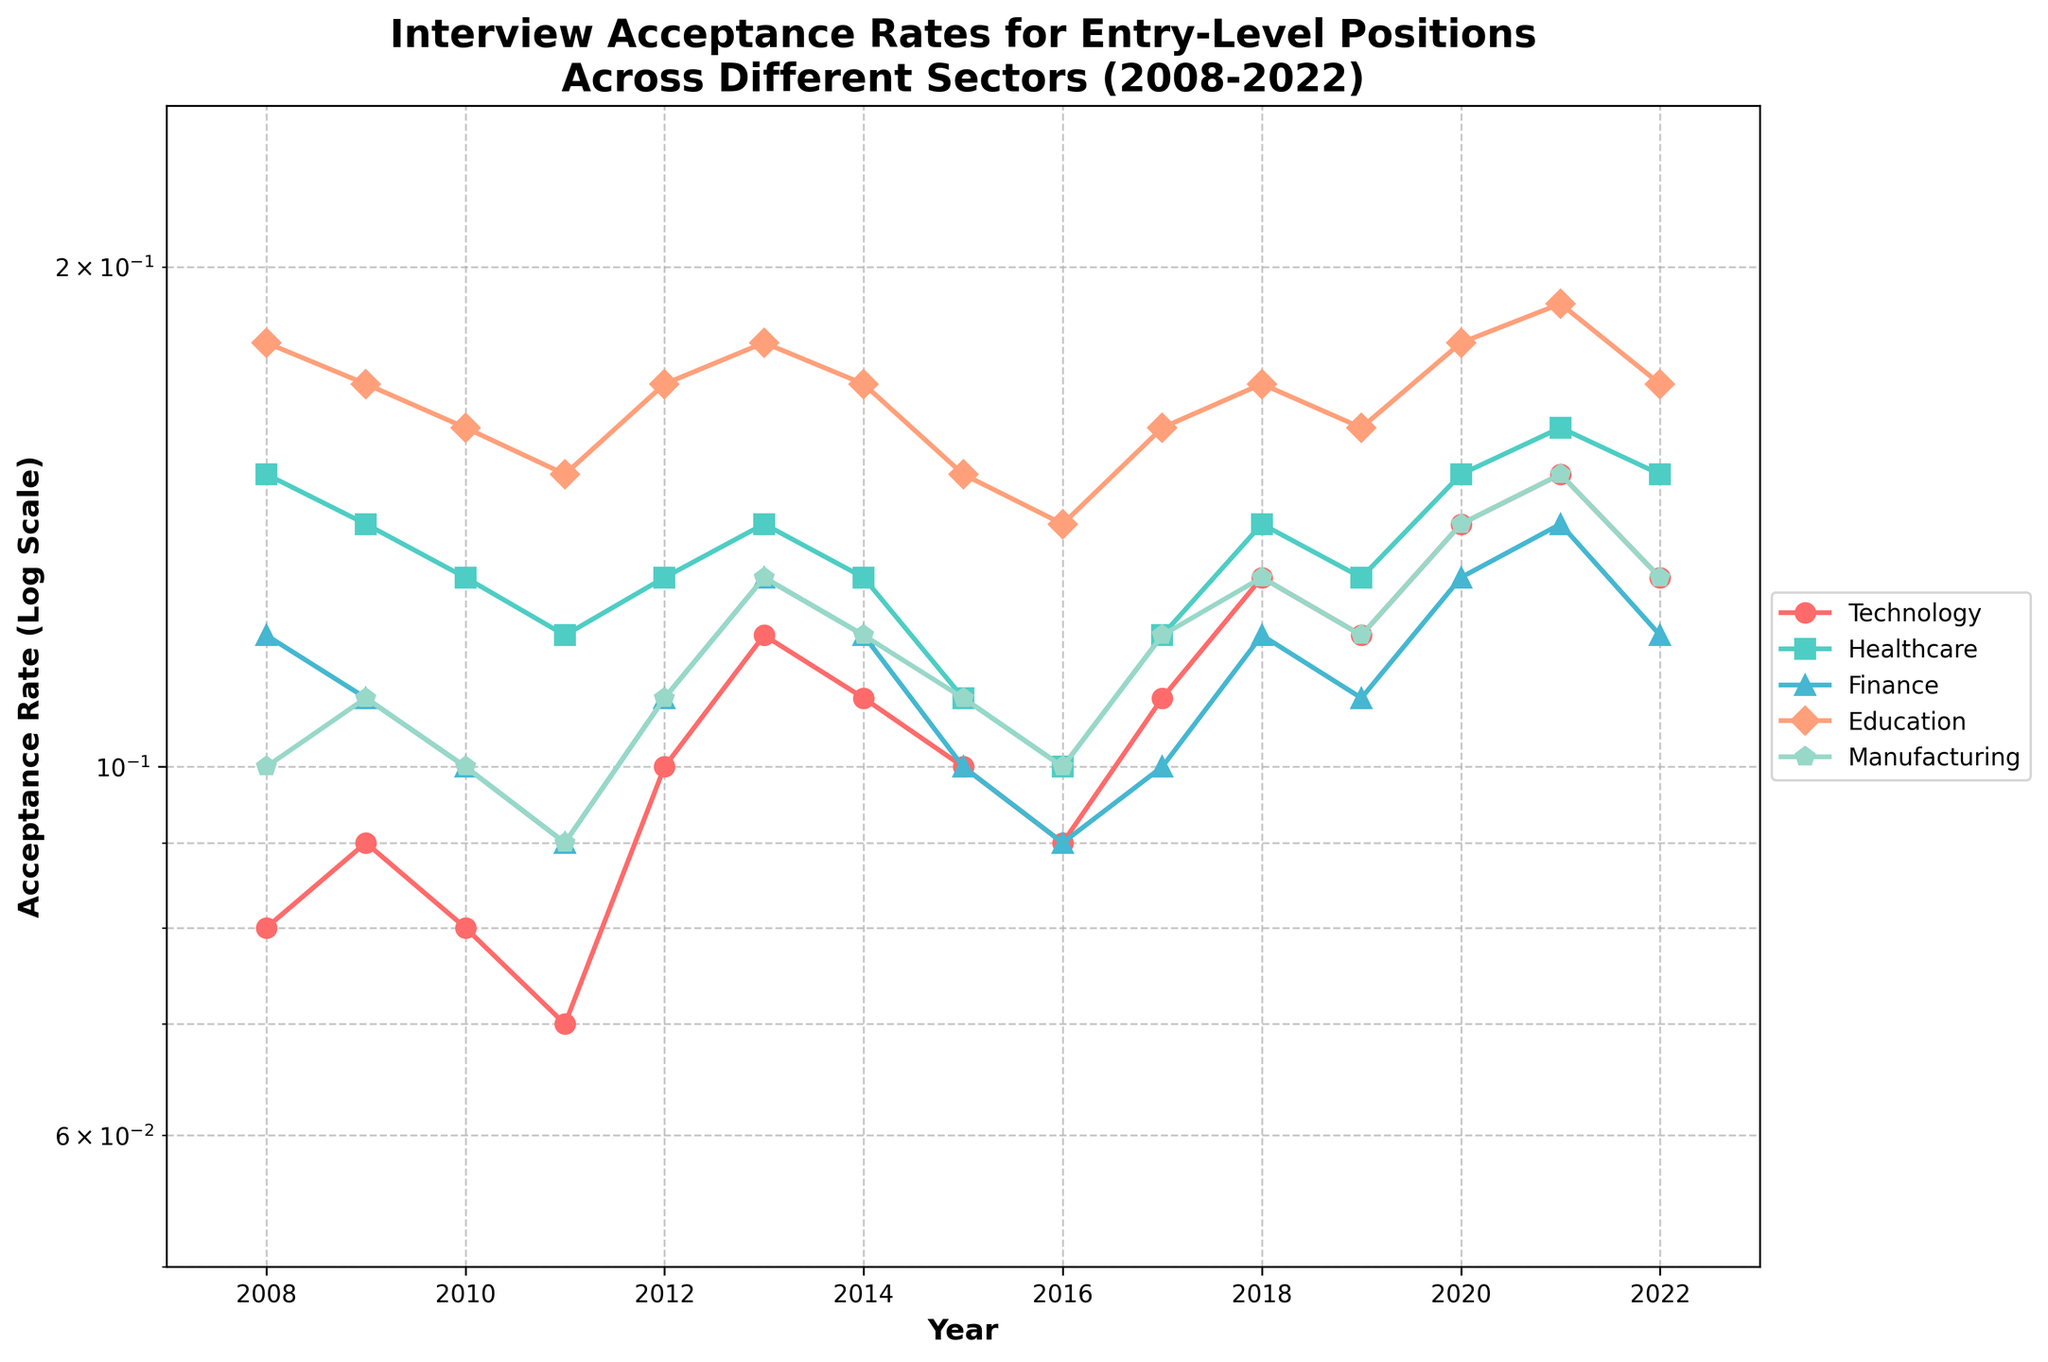What is the title of the plot? The title of the plot is located at the top and provides an overview of the visualized data.
Answer: Interview Acceptance Rates for Entry-Level Positions Across Different Sectors (2008-2022) Which sector has the highest acceptance rate in 2021? Locate the year 2021 on the x-axis, then trace upwards to identify the highest point. The highest point corresponds to Healthcare.
Answer: Healthcare How does the acceptance rate for Technology change from 2008 to 2022? Observe the line representing Technology from 2008 to 2022. The line starts at a lower point in 2008 and generally increases to a higher point in 2022.
Answer: It increases Which sector had the steepest decline in acceptance rates between any two consecutive years? Check for the lines with the steepest downward slopes between any two consecutive data points. Education shows the steepest decline between 2008 and 2009.
Answer: Education What is the overall trend for the Manufacturing sector over the 15 years? Trace the Manufacturing line from 2008 to 2022. The line shows slight fluctuations but remains fairly stable throughout the period.
Answer: Fairly stable Between which years did Healthcare reach a minimum acceptance rate? Identify the lowest point on the Healthcare line and note the corresponding years. The minimum for Healthcare occurs between 2010 and 2011.
Answer: 2010 and 2011 How do the acceptance rates for Finance and Education compare in 2013? Locate the data points for Finance and Education in 2013 and compare their heights. Both sectors have similar acceptance rates around 0.13 in that year.
Answer: Similar, around 0.13 What can you infer about acceptance rates in the Education sector in the last 5 years? Review the trend for Education from 2018 to 2022. The line shows a relatively stable trend with minor fluctuations.
Answer: Relatively stable What is the rate range of the Technology sector over the 15 years? Note the highest and lowest points on the Technology line. The range is from around 0.07 to 0.15.
Answer: 0.07 to 0.15 What was the acceptance rate trend for Finance from 2010 to 2017? Observe the Finance line between 2010 and 2017. The trend shows a slight decrease to 2012, then remains stable with minor fluctuations.
Answer: Slight decrease, then stable 